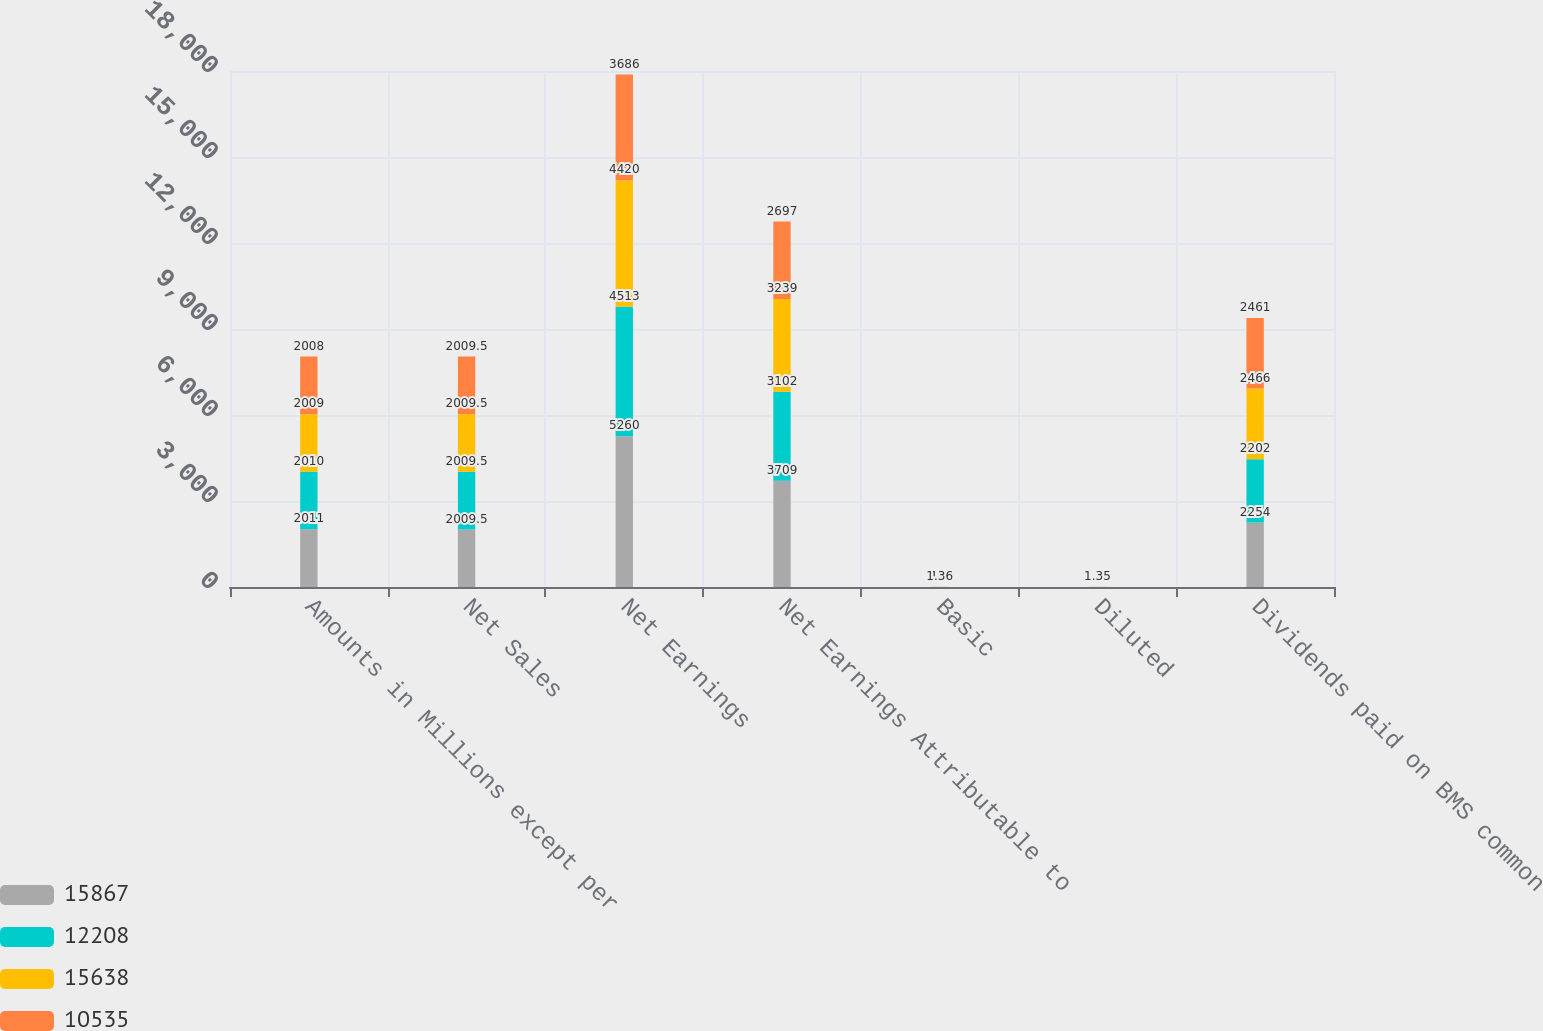<chart> <loc_0><loc_0><loc_500><loc_500><stacked_bar_chart><ecel><fcel>Amounts in Millions except per<fcel>Net Sales<fcel>Net Earnings<fcel>Net Earnings Attributable to<fcel>Basic<fcel>Diluted<fcel>Dividends paid on BMS common<nl><fcel>15867<fcel>2011<fcel>2009.5<fcel>5260<fcel>3709<fcel>2.18<fcel>2.16<fcel>2254<nl><fcel>12208<fcel>2010<fcel>2009.5<fcel>4513<fcel>3102<fcel>1.8<fcel>1.79<fcel>2202<nl><fcel>15638<fcel>2009<fcel>2009.5<fcel>4420<fcel>3239<fcel>1.63<fcel>1.63<fcel>2466<nl><fcel>10535<fcel>2008<fcel>2009.5<fcel>3686<fcel>2697<fcel>1.36<fcel>1.35<fcel>2461<nl></chart> 